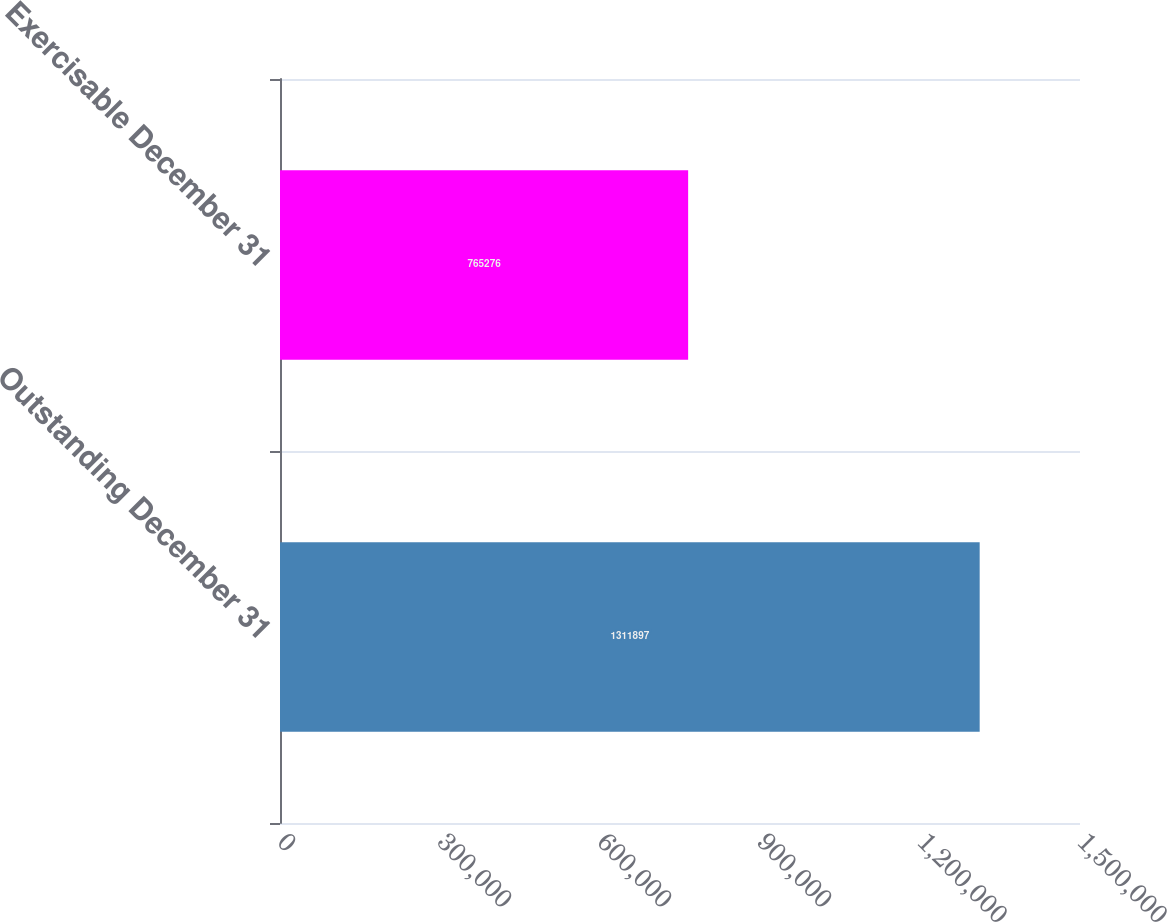Convert chart to OTSL. <chart><loc_0><loc_0><loc_500><loc_500><bar_chart><fcel>Outstanding December 31<fcel>Exercisable December 31<nl><fcel>1.3119e+06<fcel>765276<nl></chart> 